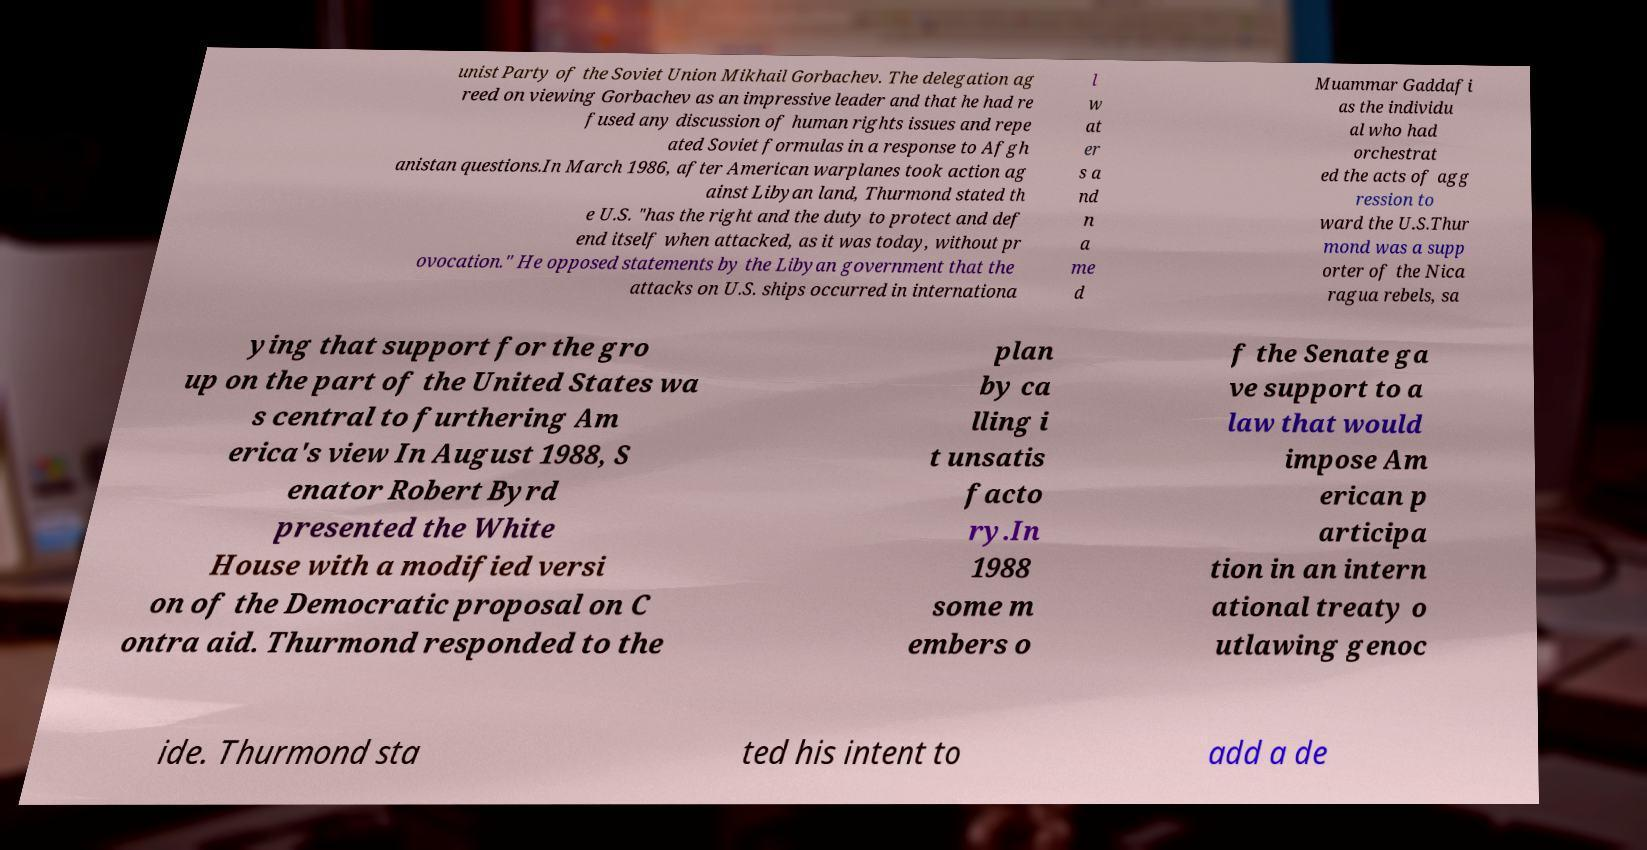Can you accurately transcribe the text from the provided image for me? unist Party of the Soviet Union Mikhail Gorbachev. The delegation ag reed on viewing Gorbachev as an impressive leader and that he had re fused any discussion of human rights issues and repe ated Soviet formulas in a response to Afgh anistan questions.In March 1986, after American warplanes took action ag ainst Libyan land, Thurmond stated th e U.S. "has the right and the duty to protect and def end itself when attacked, as it was today, without pr ovocation." He opposed statements by the Libyan government that the attacks on U.S. ships occurred in internationa l w at er s a nd n a me d Muammar Gaddafi as the individu al who had orchestrat ed the acts of agg ression to ward the U.S.Thur mond was a supp orter of the Nica ragua rebels, sa ying that support for the gro up on the part of the United States wa s central to furthering Am erica's view In August 1988, S enator Robert Byrd presented the White House with a modified versi on of the Democratic proposal on C ontra aid. Thurmond responded to the plan by ca lling i t unsatis facto ry.In 1988 some m embers o f the Senate ga ve support to a law that would impose Am erican p articipa tion in an intern ational treaty o utlawing genoc ide. Thurmond sta ted his intent to add a de 